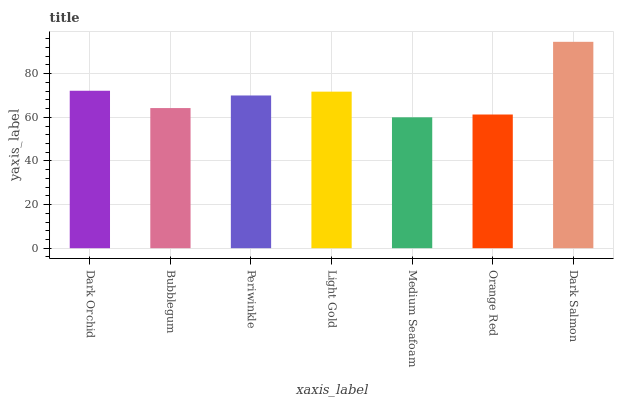Is Medium Seafoam the minimum?
Answer yes or no. Yes. Is Dark Salmon the maximum?
Answer yes or no. Yes. Is Bubblegum the minimum?
Answer yes or no. No. Is Bubblegum the maximum?
Answer yes or no. No. Is Dark Orchid greater than Bubblegum?
Answer yes or no. Yes. Is Bubblegum less than Dark Orchid?
Answer yes or no. Yes. Is Bubblegum greater than Dark Orchid?
Answer yes or no. No. Is Dark Orchid less than Bubblegum?
Answer yes or no. No. Is Periwinkle the high median?
Answer yes or no. Yes. Is Periwinkle the low median?
Answer yes or no. Yes. Is Orange Red the high median?
Answer yes or no. No. Is Dark Orchid the low median?
Answer yes or no. No. 